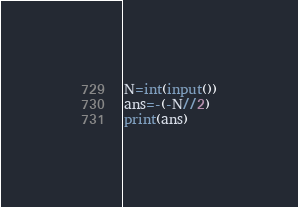<code> <loc_0><loc_0><loc_500><loc_500><_Python_>N=int(input())
ans=-(-N//2)
print(ans)</code> 